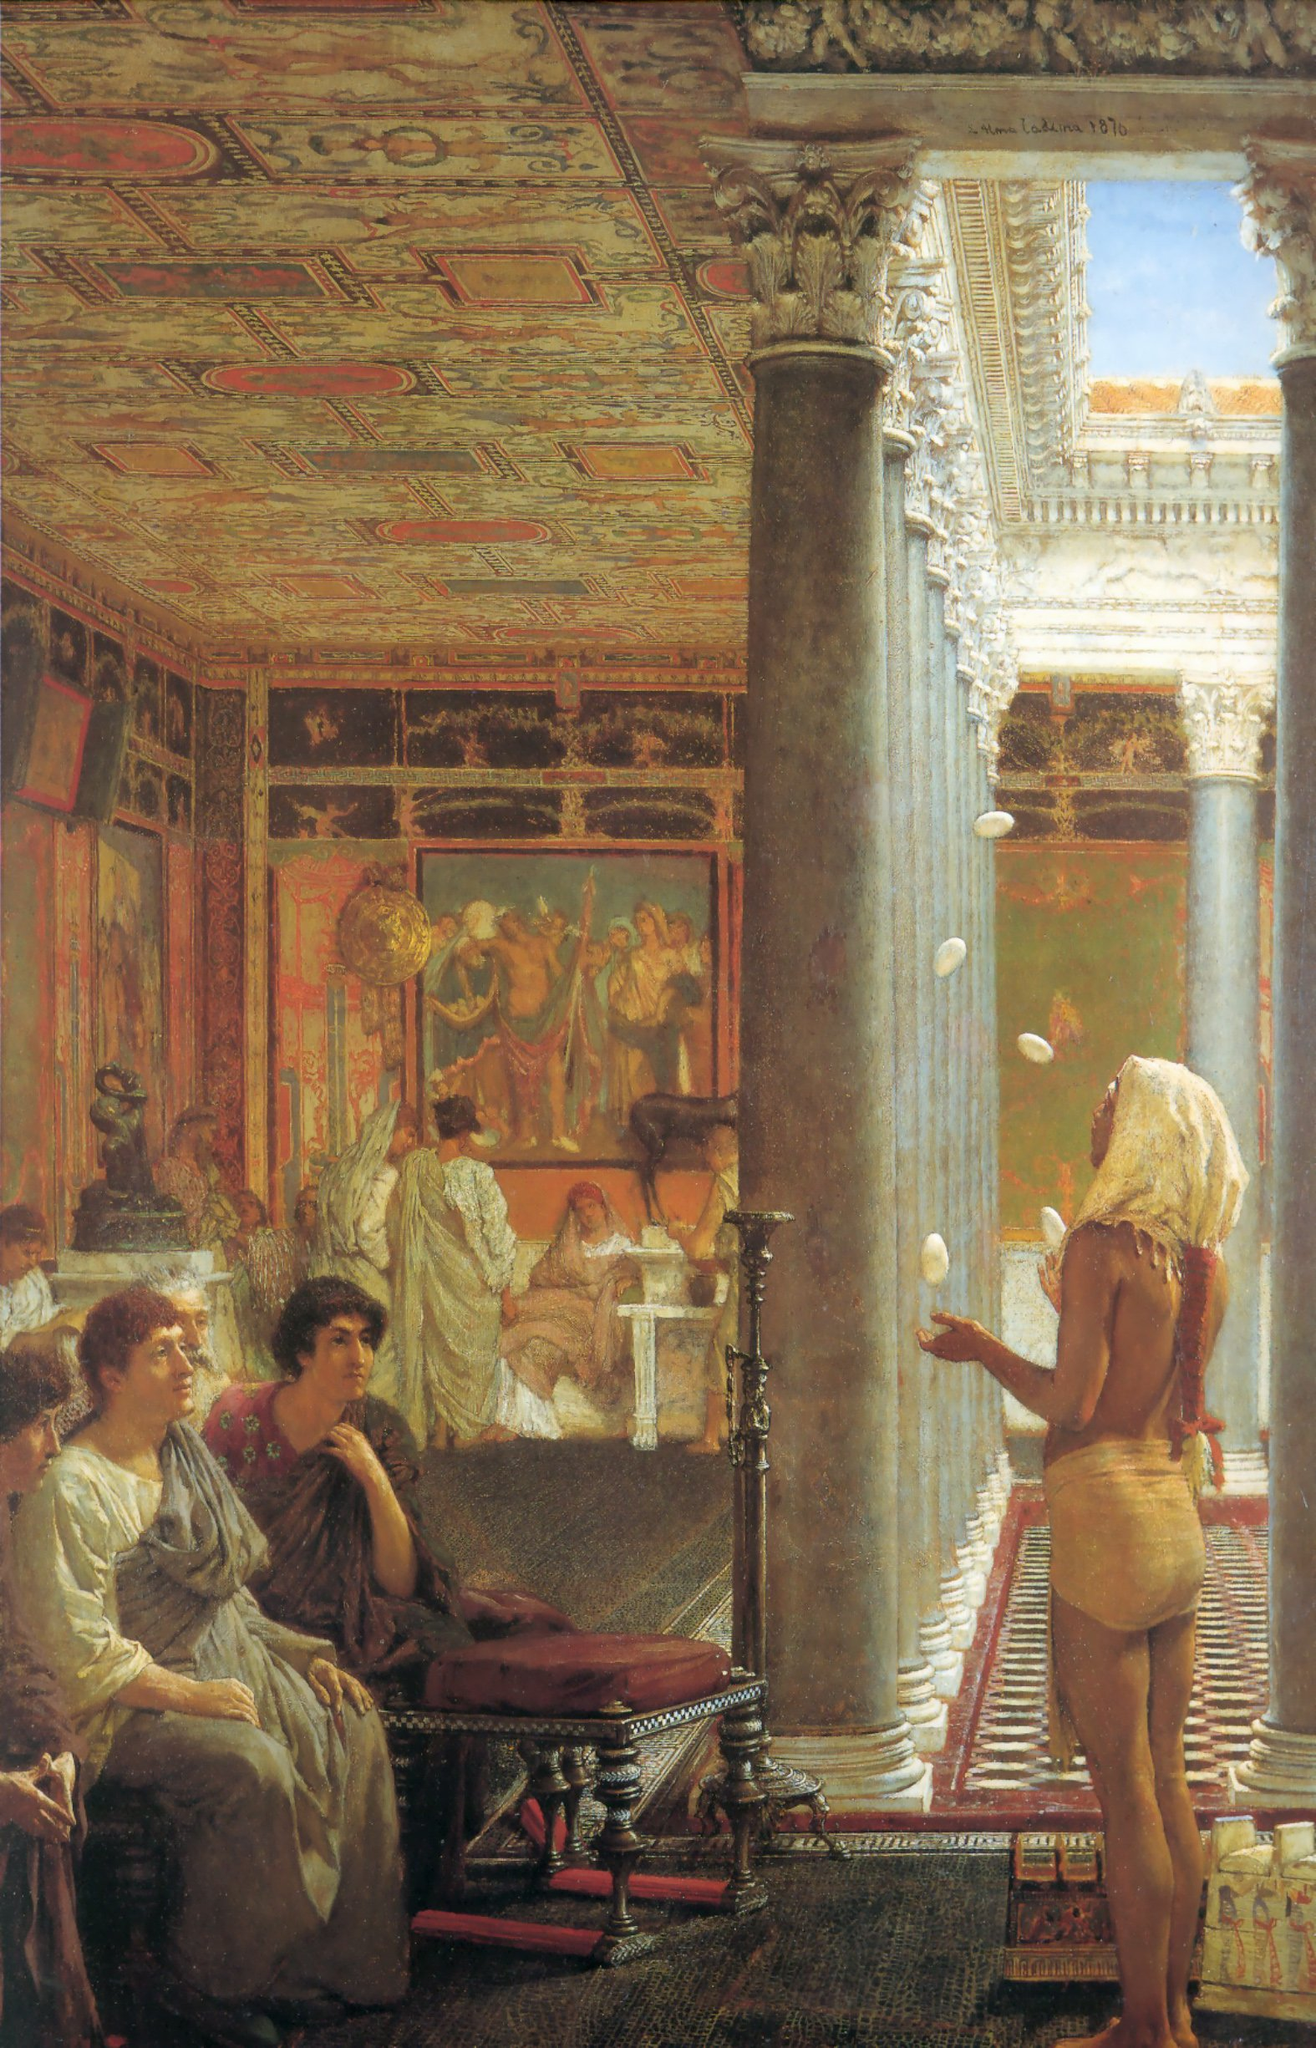Imagine this scene exists in a fantasy realm. What magical elements could be incorporated? In a fantasy realm, this scene could be transformed into an enchanting tableau filled with magical elements. The juggler could be juggling glowing orbs that change color and float in the air by their own will. The columns might be enchanted, with climbing vines that bloom into luminescent flowers whispering ancient secrets. The paintings on the walls could be moving scenes, depicting stories and characters that interact with the people in the room. The ornate ceiling could have swirling constellations that shift and respond to the conversations below, predicting futures and narrating past glories. The guests themselves could possess magical abilities, subtly using telekinesis to move objects or conjuring small illusions to entertain one another. This mystical version of the scene would create an atmosphere where magic is seamlessly woven into the fabric of daily life, enriching the luxurious setting with wonder and enchantment. 